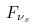<formula> <loc_0><loc_0><loc_500><loc_500>F _ { \nu _ { s } }</formula> 